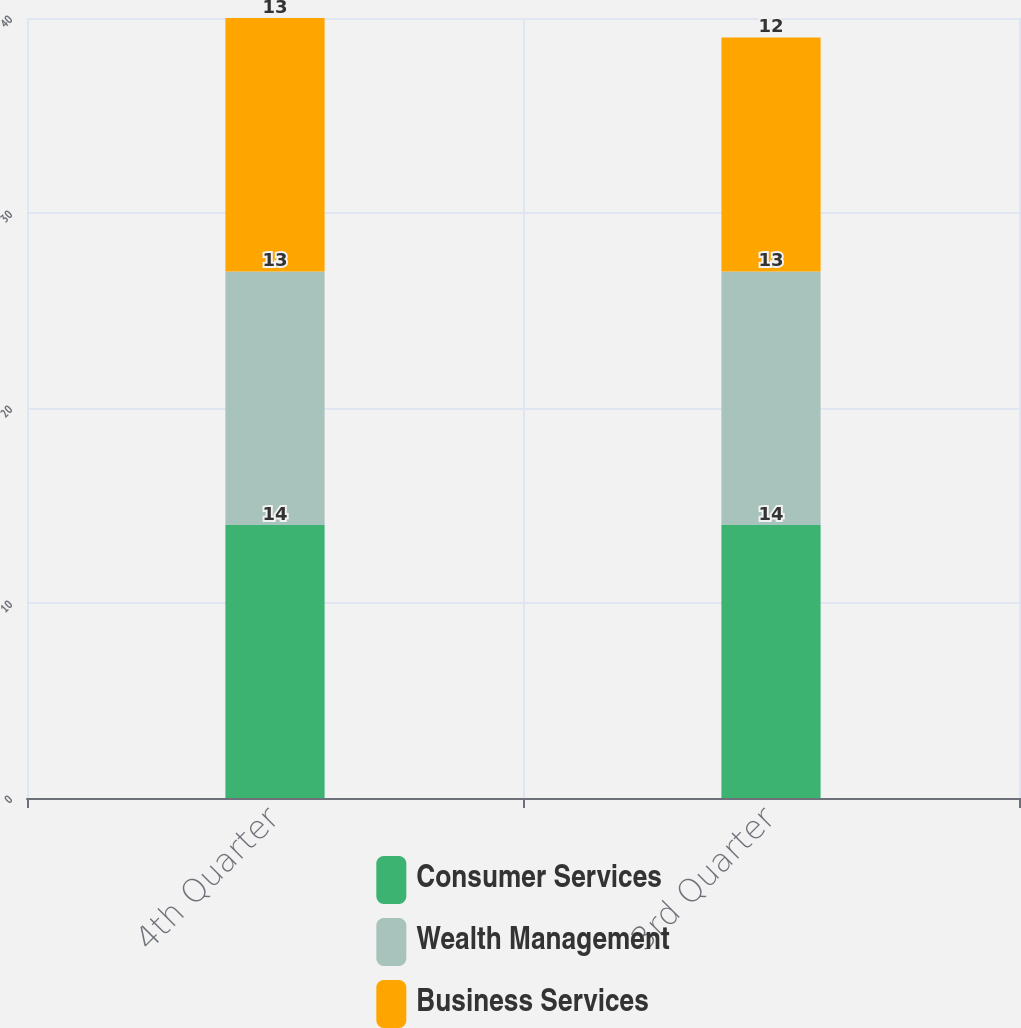Convert chart. <chart><loc_0><loc_0><loc_500><loc_500><stacked_bar_chart><ecel><fcel>4th Quarter<fcel>3rd Quarter<nl><fcel>Consumer Services<fcel>14<fcel>14<nl><fcel>Wealth Management<fcel>13<fcel>13<nl><fcel>Business Services<fcel>13<fcel>12<nl></chart> 